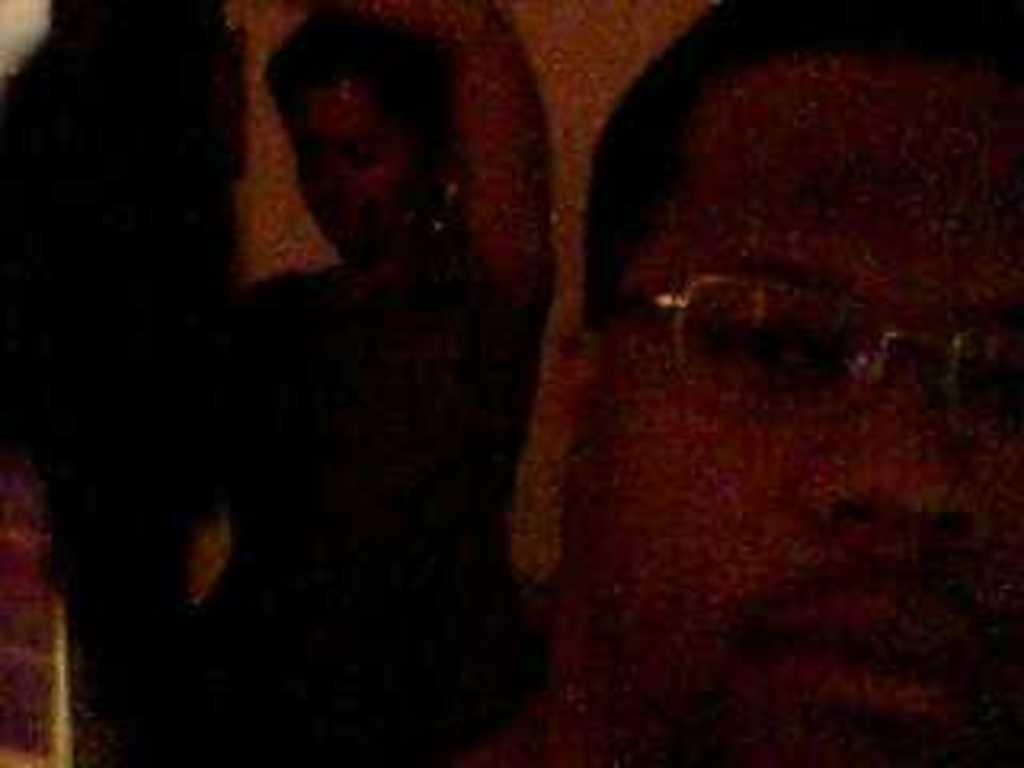What can be seen on the right side of the image? There is a person's head on the right side of the image. What is the person wearing on their face? The person is wearing spectacles. What is present on the left side of the image? There is another person on the left side of the image. How would you describe the lighting conditions in the image? The image was clicked in the dark. Can you tell me how many bees are buzzing around the person on the left side of the image? There are no bees present in the image; it only features two people. What type of servant is attending to the person on the right side of the image? There is no servant present in the image; it only features two people. 